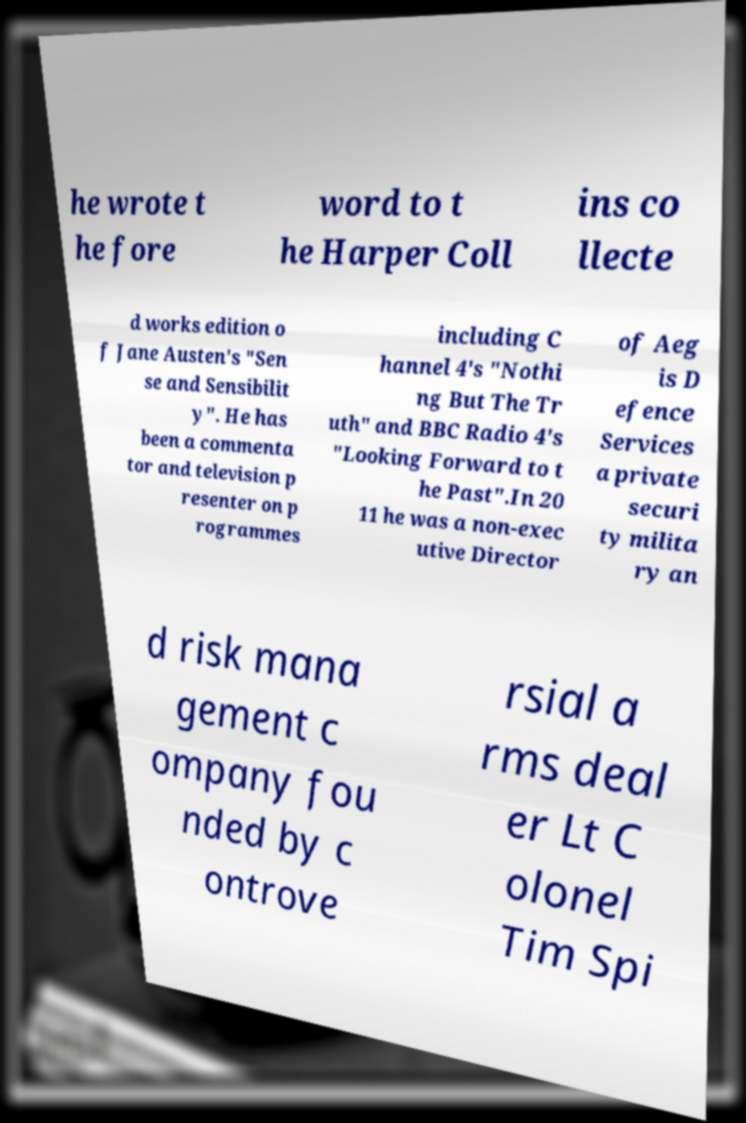Can you read and provide the text displayed in the image?This photo seems to have some interesting text. Can you extract and type it out for me? he wrote t he fore word to t he Harper Coll ins co llecte d works edition o f Jane Austen's "Sen se and Sensibilit y". He has been a commenta tor and television p resenter on p rogrammes including C hannel 4's "Nothi ng But The Tr uth" and BBC Radio 4's "Looking Forward to t he Past".In 20 11 he was a non-exec utive Director of Aeg is D efence Services a private securi ty milita ry an d risk mana gement c ompany fou nded by c ontrove rsial a rms deal er Lt C olonel Tim Spi 